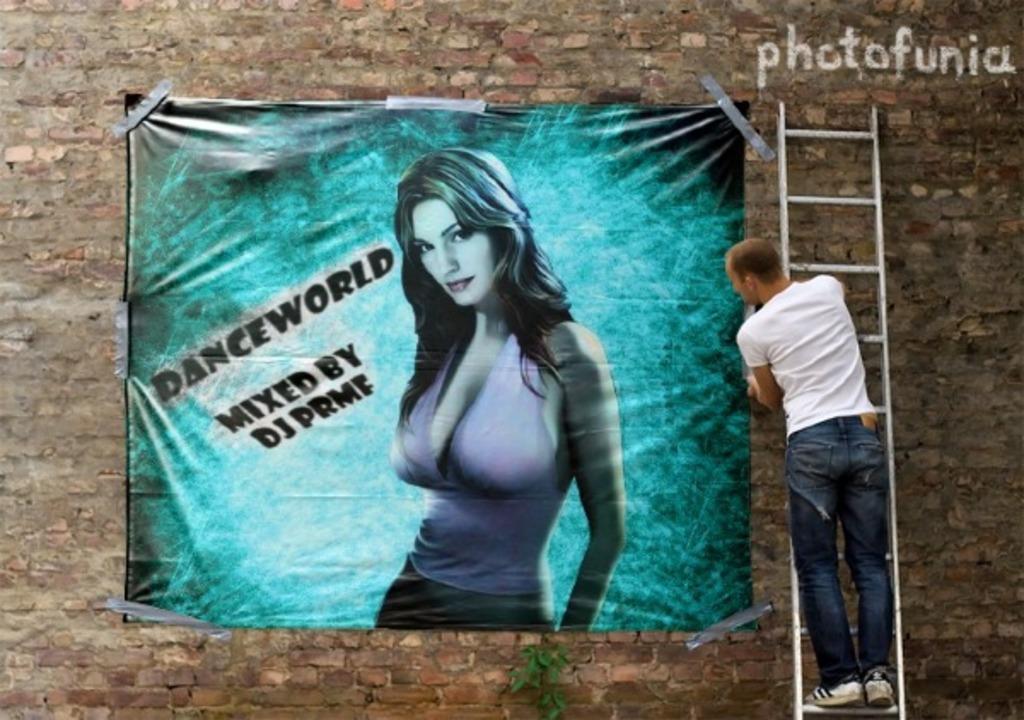What is the man in the image doing? The man is standing on a ladder. What can be seen on the wall in the image? There is a banner on the wall. What is depicted on the banner? The banner contains a picture of a woman. How many ants can be seen crawling on the banner in the image? There are no ants present on the banner in the image. What page of the book is the woman reading in the image? There is no book or woman reading in the image; it only contains a picture of a woman on the banner. 